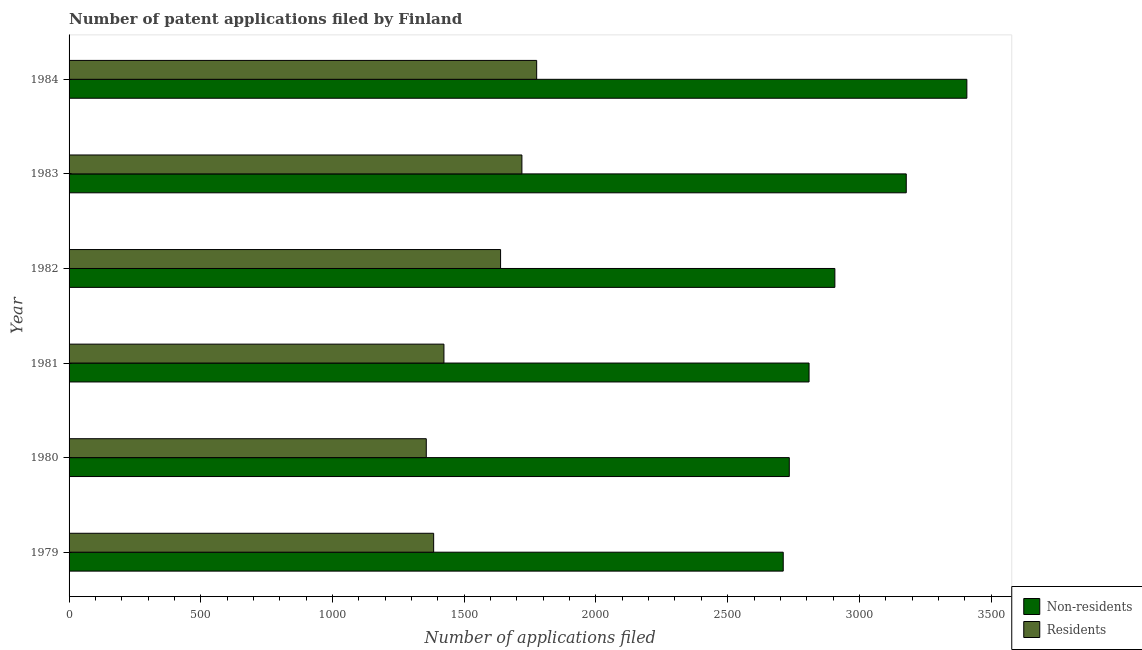How many different coloured bars are there?
Provide a succinct answer. 2. How many groups of bars are there?
Provide a short and direct response. 6. How many bars are there on the 3rd tick from the top?
Offer a terse response. 2. In how many cases, is the number of bars for a given year not equal to the number of legend labels?
Keep it short and to the point. 0. What is the number of patent applications by non residents in 1980?
Your response must be concise. 2734. Across all years, what is the maximum number of patent applications by non residents?
Your answer should be very brief. 3408. Across all years, what is the minimum number of patent applications by residents?
Make the answer very short. 1356. In which year was the number of patent applications by non residents minimum?
Your answer should be very brief. 1979. What is the total number of patent applications by non residents in the graph?
Provide a short and direct response. 1.77e+04. What is the difference between the number of patent applications by residents in 1979 and that in 1980?
Provide a short and direct response. 28. What is the average number of patent applications by non residents per year?
Provide a short and direct response. 2957.83. In the year 1982, what is the difference between the number of patent applications by residents and number of patent applications by non residents?
Keep it short and to the point. -1269. In how many years, is the number of patent applications by residents greater than 1700 ?
Keep it short and to the point. 2. What is the ratio of the number of patent applications by residents in 1979 to that in 1982?
Provide a short and direct response. 0.84. Is the difference between the number of patent applications by non residents in 1979 and 1984 greater than the difference between the number of patent applications by residents in 1979 and 1984?
Make the answer very short. No. What is the difference between the highest and the second highest number of patent applications by non residents?
Provide a short and direct response. 230. What is the difference between the highest and the lowest number of patent applications by non residents?
Provide a short and direct response. 697. Is the sum of the number of patent applications by residents in 1979 and 1981 greater than the maximum number of patent applications by non residents across all years?
Provide a short and direct response. No. What does the 1st bar from the top in 1979 represents?
Provide a succinct answer. Residents. What does the 1st bar from the bottom in 1983 represents?
Your answer should be very brief. Non-residents. Are all the bars in the graph horizontal?
Make the answer very short. Yes. How many years are there in the graph?
Keep it short and to the point. 6. What is the difference between two consecutive major ticks on the X-axis?
Your answer should be very brief. 500. Are the values on the major ticks of X-axis written in scientific E-notation?
Keep it short and to the point. No. Does the graph contain any zero values?
Your answer should be very brief. No. Where does the legend appear in the graph?
Offer a very short reply. Bottom right. What is the title of the graph?
Ensure brevity in your answer.  Number of patent applications filed by Finland. Does "Automatic Teller Machines" appear as one of the legend labels in the graph?
Offer a terse response. No. What is the label or title of the X-axis?
Your response must be concise. Number of applications filed. What is the Number of applications filed of Non-residents in 1979?
Provide a succinct answer. 2711. What is the Number of applications filed in Residents in 1979?
Offer a terse response. 1384. What is the Number of applications filed in Non-residents in 1980?
Provide a short and direct response. 2734. What is the Number of applications filed of Residents in 1980?
Offer a terse response. 1356. What is the Number of applications filed in Non-residents in 1981?
Offer a very short reply. 2809. What is the Number of applications filed of Residents in 1981?
Offer a terse response. 1423. What is the Number of applications filed in Non-residents in 1982?
Give a very brief answer. 2907. What is the Number of applications filed in Residents in 1982?
Ensure brevity in your answer.  1638. What is the Number of applications filed in Non-residents in 1983?
Offer a terse response. 3178. What is the Number of applications filed in Residents in 1983?
Keep it short and to the point. 1719. What is the Number of applications filed of Non-residents in 1984?
Ensure brevity in your answer.  3408. What is the Number of applications filed in Residents in 1984?
Give a very brief answer. 1775. Across all years, what is the maximum Number of applications filed of Non-residents?
Keep it short and to the point. 3408. Across all years, what is the maximum Number of applications filed of Residents?
Your answer should be compact. 1775. Across all years, what is the minimum Number of applications filed of Non-residents?
Ensure brevity in your answer.  2711. Across all years, what is the minimum Number of applications filed in Residents?
Give a very brief answer. 1356. What is the total Number of applications filed in Non-residents in the graph?
Give a very brief answer. 1.77e+04. What is the total Number of applications filed in Residents in the graph?
Provide a succinct answer. 9295. What is the difference between the Number of applications filed of Non-residents in 1979 and that in 1981?
Ensure brevity in your answer.  -98. What is the difference between the Number of applications filed in Residents in 1979 and that in 1981?
Give a very brief answer. -39. What is the difference between the Number of applications filed of Non-residents in 1979 and that in 1982?
Give a very brief answer. -196. What is the difference between the Number of applications filed of Residents in 1979 and that in 1982?
Ensure brevity in your answer.  -254. What is the difference between the Number of applications filed of Non-residents in 1979 and that in 1983?
Ensure brevity in your answer.  -467. What is the difference between the Number of applications filed in Residents in 1979 and that in 1983?
Offer a very short reply. -335. What is the difference between the Number of applications filed in Non-residents in 1979 and that in 1984?
Offer a very short reply. -697. What is the difference between the Number of applications filed in Residents in 1979 and that in 1984?
Provide a short and direct response. -391. What is the difference between the Number of applications filed of Non-residents in 1980 and that in 1981?
Your answer should be compact. -75. What is the difference between the Number of applications filed in Residents in 1980 and that in 1981?
Give a very brief answer. -67. What is the difference between the Number of applications filed of Non-residents in 1980 and that in 1982?
Your answer should be compact. -173. What is the difference between the Number of applications filed of Residents in 1980 and that in 1982?
Keep it short and to the point. -282. What is the difference between the Number of applications filed of Non-residents in 1980 and that in 1983?
Your answer should be very brief. -444. What is the difference between the Number of applications filed of Residents in 1980 and that in 1983?
Your answer should be compact. -363. What is the difference between the Number of applications filed in Non-residents in 1980 and that in 1984?
Give a very brief answer. -674. What is the difference between the Number of applications filed of Residents in 1980 and that in 1984?
Your answer should be compact. -419. What is the difference between the Number of applications filed in Non-residents in 1981 and that in 1982?
Your answer should be compact. -98. What is the difference between the Number of applications filed of Residents in 1981 and that in 1982?
Offer a very short reply. -215. What is the difference between the Number of applications filed of Non-residents in 1981 and that in 1983?
Provide a short and direct response. -369. What is the difference between the Number of applications filed of Residents in 1981 and that in 1983?
Give a very brief answer. -296. What is the difference between the Number of applications filed of Non-residents in 1981 and that in 1984?
Your answer should be compact. -599. What is the difference between the Number of applications filed of Residents in 1981 and that in 1984?
Keep it short and to the point. -352. What is the difference between the Number of applications filed of Non-residents in 1982 and that in 1983?
Give a very brief answer. -271. What is the difference between the Number of applications filed of Residents in 1982 and that in 1983?
Keep it short and to the point. -81. What is the difference between the Number of applications filed in Non-residents in 1982 and that in 1984?
Your response must be concise. -501. What is the difference between the Number of applications filed in Residents in 1982 and that in 1984?
Your answer should be very brief. -137. What is the difference between the Number of applications filed in Non-residents in 1983 and that in 1984?
Your answer should be compact. -230. What is the difference between the Number of applications filed of Residents in 1983 and that in 1984?
Your answer should be compact. -56. What is the difference between the Number of applications filed in Non-residents in 1979 and the Number of applications filed in Residents in 1980?
Provide a short and direct response. 1355. What is the difference between the Number of applications filed of Non-residents in 1979 and the Number of applications filed of Residents in 1981?
Offer a very short reply. 1288. What is the difference between the Number of applications filed in Non-residents in 1979 and the Number of applications filed in Residents in 1982?
Your answer should be compact. 1073. What is the difference between the Number of applications filed in Non-residents in 1979 and the Number of applications filed in Residents in 1983?
Your answer should be very brief. 992. What is the difference between the Number of applications filed of Non-residents in 1979 and the Number of applications filed of Residents in 1984?
Make the answer very short. 936. What is the difference between the Number of applications filed in Non-residents in 1980 and the Number of applications filed in Residents in 1981?
Keep it short and to the point. 1311. What is the difference between the Number of applications filed in Non-residents in 1980 and the Number of applications filed in Residents in 1982?
Your response must be concise. 1096. What is the difference between the Number of applications filed of Non-residents in 1980 and the Number of applications filed of Residents in 1983?
Your answer should be compact. 1015. What is the difference between the Number of applications filed in Non-residents in 1980 and the Number of applications filed in Residents in 1984?
Your answer should be very brief. 959. What is the difference between the Number of applications filed in Non-residents in 1981 and the Number of applications filed in Residents in 1982?
Your response must be concise. 1171. What is the difference between the Number of applications filed of Non-residents in 1981 and the Number of applications filed of Residents in 1983?
Ensure brevity in your answer.  1090. What is the difference between the Number of applications filed in Non-residents in 1981 and the Number of applications filed in Residents in 1984?
Offer a terse response. 1034. What is the difference between the Number of applications filed in Non-residents in 1982 and the Number of applications filed in Residents in 1983?
Your response must be concise. 1188. What is the difference between the Number of applications filed of Non-residents in 1982 and the Number of applications filed of Residents in 1984?
Give a very brief answer. 1132. What is the difference between the Number of applications filed in Non-residents in 1983 and the Number of applications filed in Residents in 1984?
Offer a terse response. 1403. What is the average Number of applications filed of Non-residents per year?
Give a very brief answer. 2957.83. What is the average Number of applications filed in Residents per year?
Make the answer very short. 1549.17. In the year 1979, what is the difference between the Number of applications filed in Non-residents and Number of applications filed in Residents?
Your answer should be very brief. 1327. In the year 1980, what is the difference between the Number of applications filed in Non-residents and Number of applications filed in Residents?
Ensure brevity in your answer.  1378. In the year 1981, what is the difference between the Number of applications filed of Non-residents and Number of applications filed of Residents?
Provide a succinct answer. 1386. In the year 1982, what is the difference between the Number of applications filed in Non-residents and Number of applications filed in Residents?
Provide a short and direct response. 1269. In the year 1983, what is the difference between the Number of applications filed of Non-residents and Number of applications filed of Residents?
Ensure brevity in your answer.  1459. In the year 1984, what is the difference between the Number of applications filed of Non-residents and Number of applications filed of Residents?
Offer a terse response. 1633. What is the ratio of the Number of applications filed in Residents in 1979 to that in 1980?
Give a very brief answer. 1.02. What is the ratio of the Number of applications filed in Non-residents in 1979 to that in 1981?
Make the answer very short. 0.97. What is the ratio of the Number of applications filed of Residents in 1979 to that in 1981?
Your answer should be very brief. 0.97. What is the ratio of the Number of applications filed of Non-residents in 1979 to that in 1982?
Your answer should be compact. 0.93. What is the ratio of the Number of applications filed in Residents in 1979 to that in 1982?
Keep it short and to the point. 0.84. What is the ratio of the Number of applications filed in Non-residents in 1979 to that in 1983?
Offer a very short reply. 0.85. What is the ratio of the Number of applications filed of Residents in 1979 to that in 1983?
Provide a short and direct response. 0.81. What is the ratio of the Number of applications filed in Non-residents in 1979 to that in 1984?
Your answer should be very brief. 0.8. What is the ratio of the Number of applications filed of Residents in 1979 to that in 1984?
Your answer should be compact. 0.78. What is the ratio of the Number of applications filed in Non-residents in 1980 to that in 1981?
Provide a succinct answer. 0.97. What is the ratio of the Number of applications filed of Residents in 1980 to that in 1981?
Provide a succinct answer. 0.95. What is the ratio of the Number of applications filed in Non-residents in 1980 to that in 1982?
Your response must be concise. 0.94. What is the ratio of the Number of applications filed of Residents in 1980 to that in 1982?
Your answer should be compact. 0.83. What is the ratio of the Number of applications filed of Non-residents in 1980 to that in 1983?
Offer a very short reply. 0.86. What is the ratio of the Number of applications filed of Residents in 1980 to that in 1983?
Keep it short and to the point. 0.79. What is the ratio of the Number of applications filed of Non-residents in 1980 to that in 1984?
Keep it short and to the point. 0.8. What is the ratio of the Number of applications filed of Residents in 1980 to that in 1984?
Your answer should be very brief. 0.76. What is the ratio of the Number of applications filed of Non-residents in 1981 to that in 1982?
Keep it short and to the point. 0.97. What is the ratio of the Number of applications filed in Residents in 1981 to that in 1982?
Your answer should be compact. 0.87. What is the ratio of the Number of applications filed of Non-residents in 1981 to that in 1983?
Your answer should be very brief. 0.88. What is the ratio of the Number of applications filed of Residents in 1981 to that in 1983?
Keep it short and to the point. 0.83. What is the ratio of the Number of applications filed in Non-residents in 1981 to that in 1984?
Make the answer very short. 0.82. What is the ratio of the Number of applications filed in Residents in 1981 to that in 1984?
Make the answer very short. 0.8. What is the ratio of the Number of applications filed in Non-residents in 1982 to that in 1983?
Provide a short and direct response. 0.91. What is the ratio of the Number of applications filed of Residents in 1982 to that in 1983?
Provide a short and direct response. 0.95. What is the ratio of the Number of applications filed of Non-residents in 1982 to that in 1984?
Make the answer very short. 0.85. What is the ratio of the Number of applications filed of Residents in 1982 to that in 1984?
Give a very brief answer. 0.92. What is the ratio of the Number of applications filed in Non-residents in 1983 to that in 1984?
Your answer should be very brief. 0.93. What is the ratio of the Number of applications filed in Residents in 1983 to that in 1984?
Provide a succinct answer. 0.97. What is the difference between the highest and the second highest Number of applications filed in Non-residents?
Provide a succinct answer. 230. What is the difference between the highest and the second highest Number of applications filed of Residents?
Give a very brief answer. 56. What is the difference between the highest and the lowest Number of applications filed in Non-residents?
Keep it short and to the point. 697. What is the difference between the highest and the lowest Number of applications filed in Residents?
Offer a terse response. 419. 